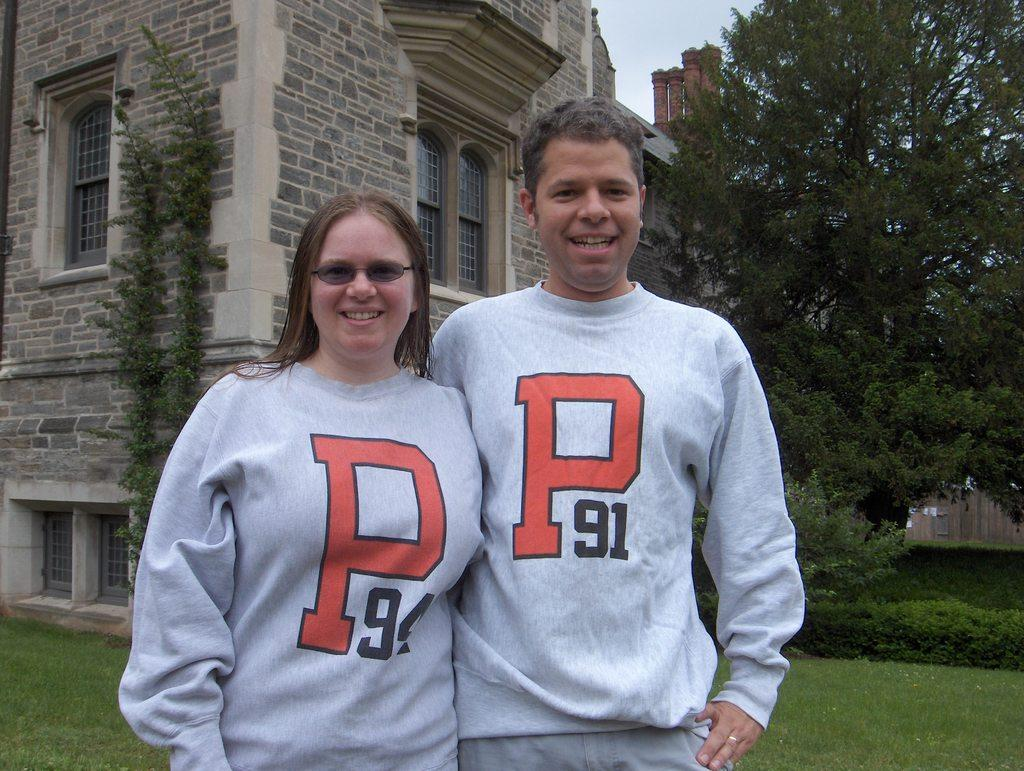<image>
Give a short and clear explanation of the subsequent image. A man and a woman wearing shirts that have the letter P and a number. 